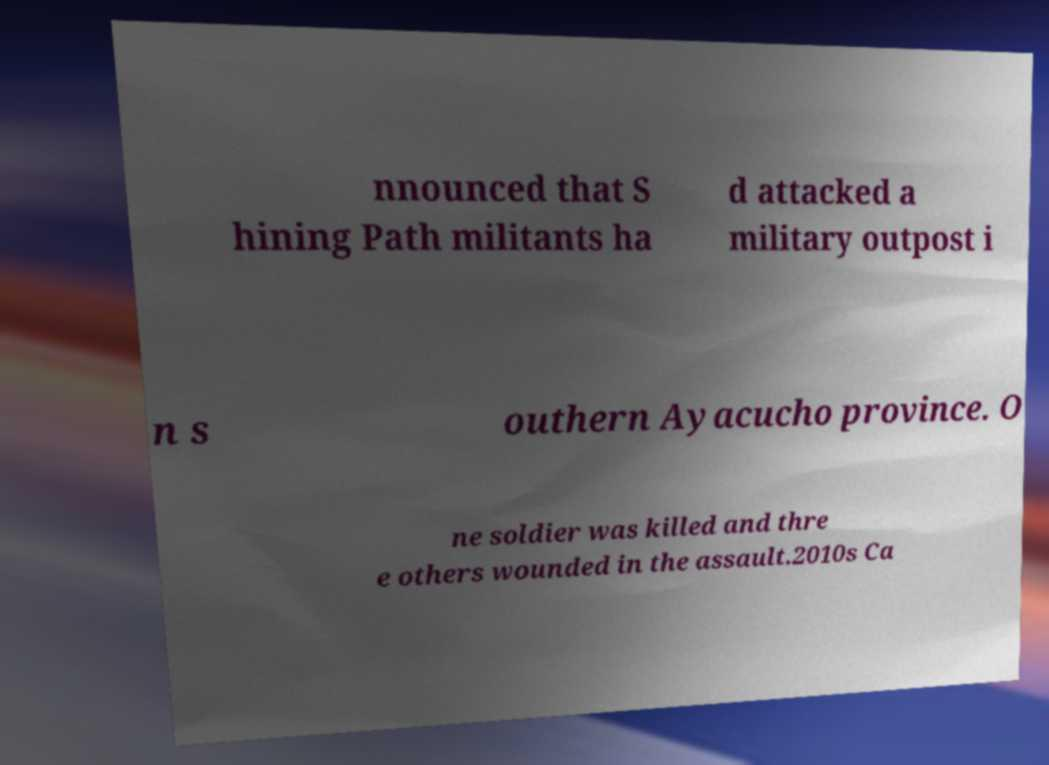What messages or text are displayed in this image? I need them in a readable, typed format. nnounced that S hining Path militants ha d attacked a military outpost i n s outhern Ayacucho province. O ne soldier was killed and thre e others wounded in the assault.2010s Ca 